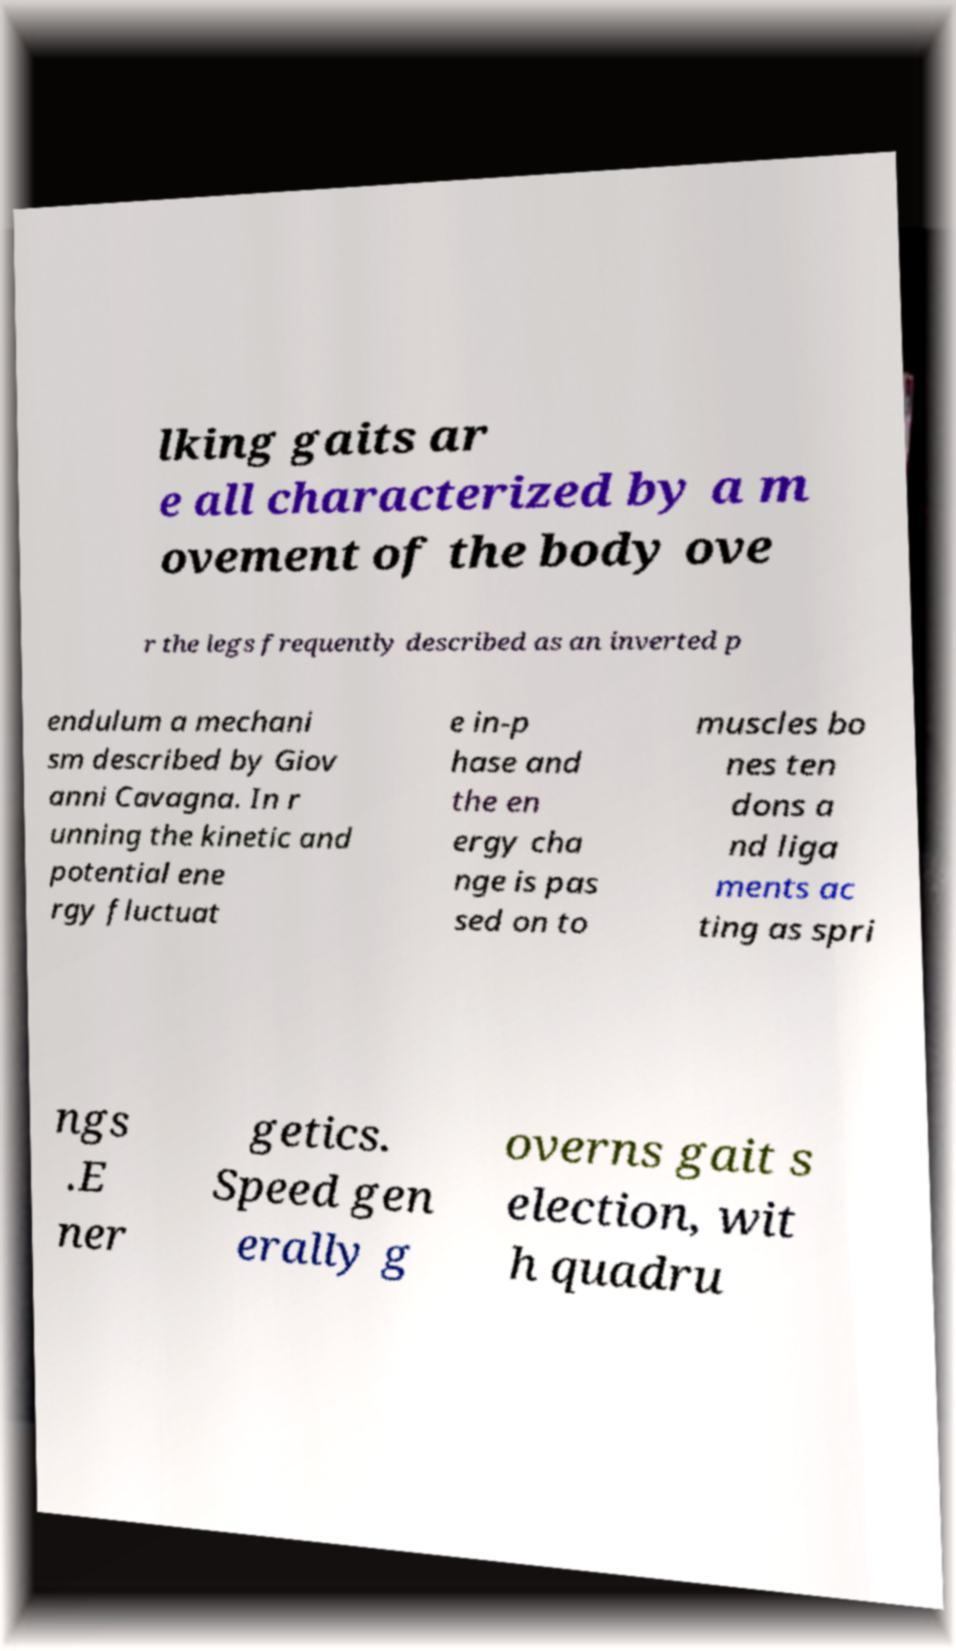What messages or text are displayed in this image? I need them in a readable, typed format. lking gaits ar e all characterized by a m ovement of the body ove r the legs frequently described as an inverted p endulum a mechani sm described by Giov anni Cavagna. In r unning the kinetic and potential ene rgy fluctuat e in-p hase and the en ergy cha nge is pas sed on to muscles bo nes ten dons a nd liga ments ac ting as spri ngs .E ner getics. Speed gen erally g overns gait s election, wit h quadru 